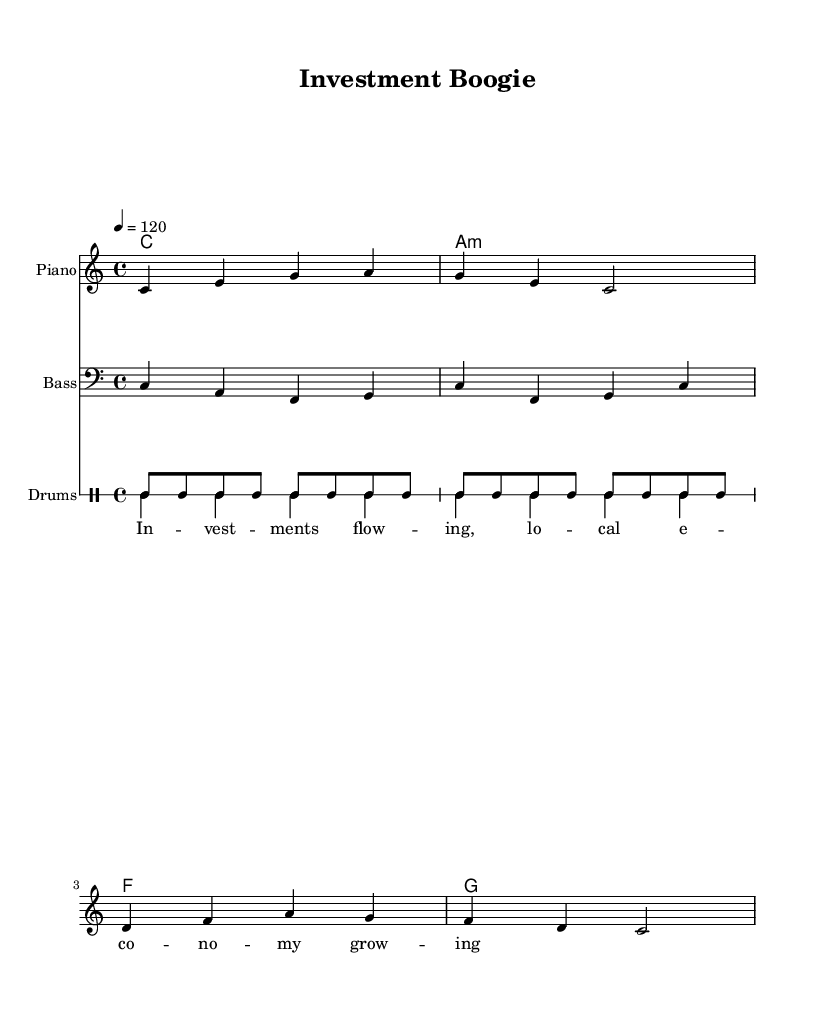What is the key signature of this music? The key signature is indicated by the absence of sharps or flats on the staff, which corresponds to C major.
Answer: C major What is the time signature of this music? The time signature is shown at the beginning of the sheet music as 4/4, meaning there are four beats per measure and the quarter note gets one beat.
Answer: 4/4 What is the tempo marking for this music? The tempo marking is indicated in the score, stating 4 = 120, which means to play at 120 beats per minute.
Answer: 120 What are the primary chords used in the harmony? The harmony section shows the chords C major, A minor, F major, and G major, which are commonly used in disco music.
Answer: C, A minor, F, G How does the bass line interact with the melody? The bass line provides a rhythmic foundation by playing a complementary pattern that enhances the groove of the melody, common in disco genres.
Answer: Enhances groove What is the lyrical theme of the song? The lyrics state "Investments flowing, local economy growing," reflecting the focus on economic transformation through investment.
Answer: Economic transformation What style of music is represented by this sheet music? The upbeat tempo, syncopated rhythms, and lively chords are characteristics of disco, a genre that focuses on danceability and community.
Answer: Disco 